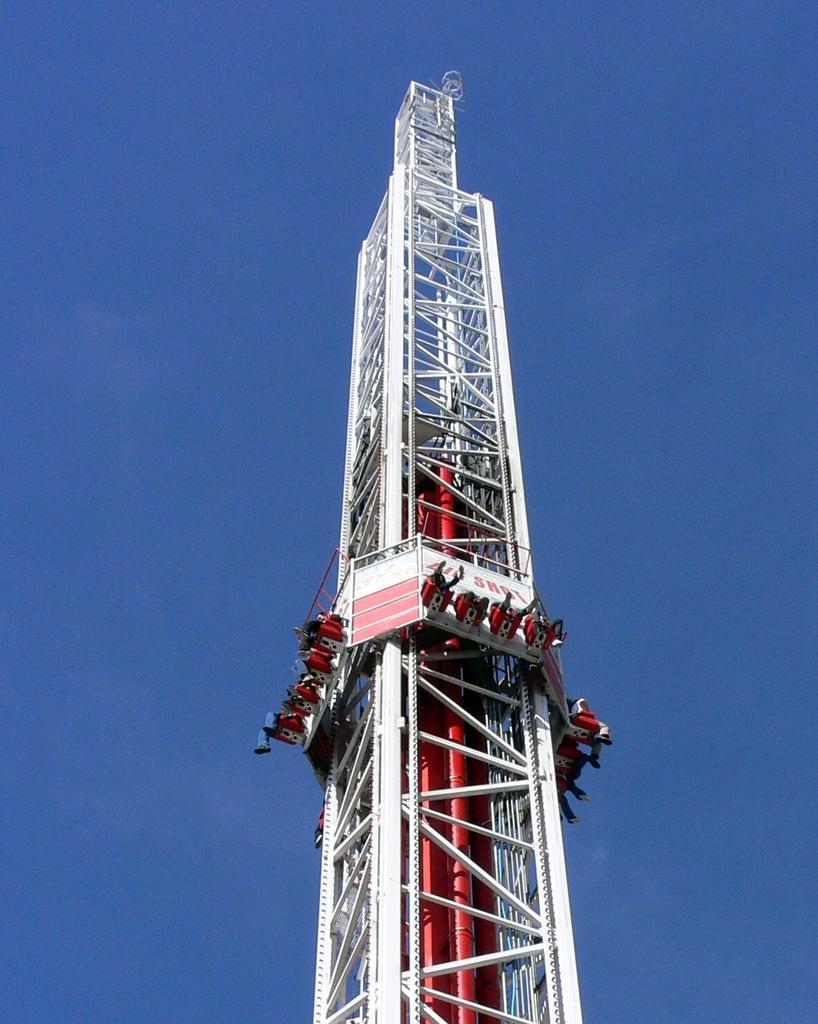Describe this image in one or two sentences. In this picture we can see a ride, in which we can see some people and it looks like a tower. 